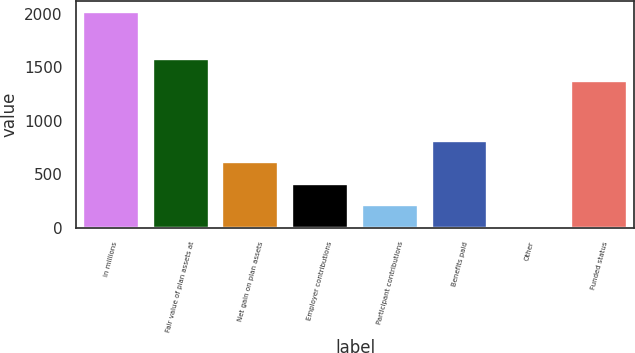Convert chart. <chart><loc_0><loc_0><loc_500><loc_500><bar_chart><fcel>in millions<fcel>Fair value of plan assets at<fcel>Net gain on plan assets<fcel>Employer contributions<fcel>Participant contributions<fcel>Benefits paid<fcel>Other<fcel>Funded status<nl><fcel>2014<fcel>1575.4<fcel>612.6<fcel>412.4<fcel>212.2<fcel>812.8<fcel>12<fcel>1375.2<nl></chart> 